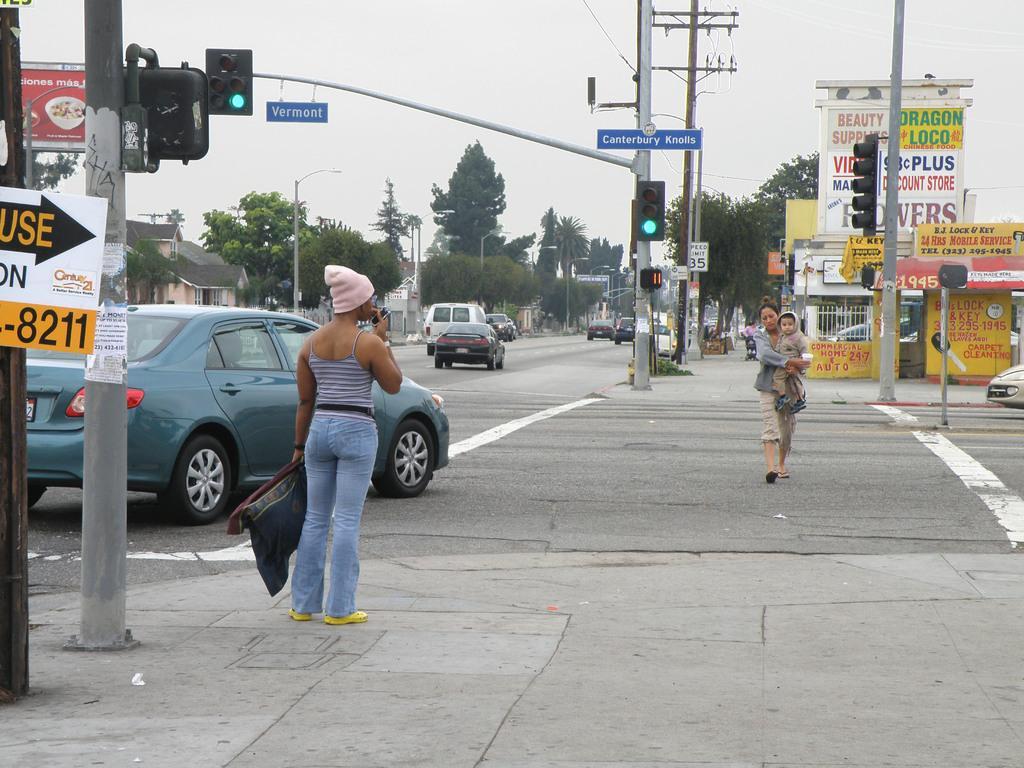Describe this image in one or two sentences. In this image we can see persons standing on the road and one of them is holding a baby in her hands. In the background we can see motor vehicles, trees, street poles, street lights, traffic poles, traffic signals, advertisement boards, buildings and sky. 